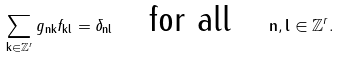Convert formula to latex. <formula><loc_0><loc_0><loc_500><loc_500>\sum _ { \mathbf k \in \mathbb { Z } ^ { r } } g _ { \mathbf n \mathbf k } f _ { \mathbf k \mathbf l } = \delta _ { \mathbf n \mathbf l } \quad \text {for all} \quad \mathbf n , \mathbf l \in \mathbb { Z } ^ { r } .</formula> 